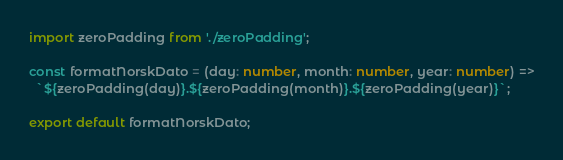Convert code to text. <code><loc_0><loc_0><loc_500><loc_500><_TypeScript_>import zeroPadding from './zeroPadding';

const formatNorskDato = (day: number, month: number, year: number) =>
  `${zeroPadding(day)}.${zeroPadding(month)}.${zeroPadding(year)}`;

export default formatNorskDato;
</code> 